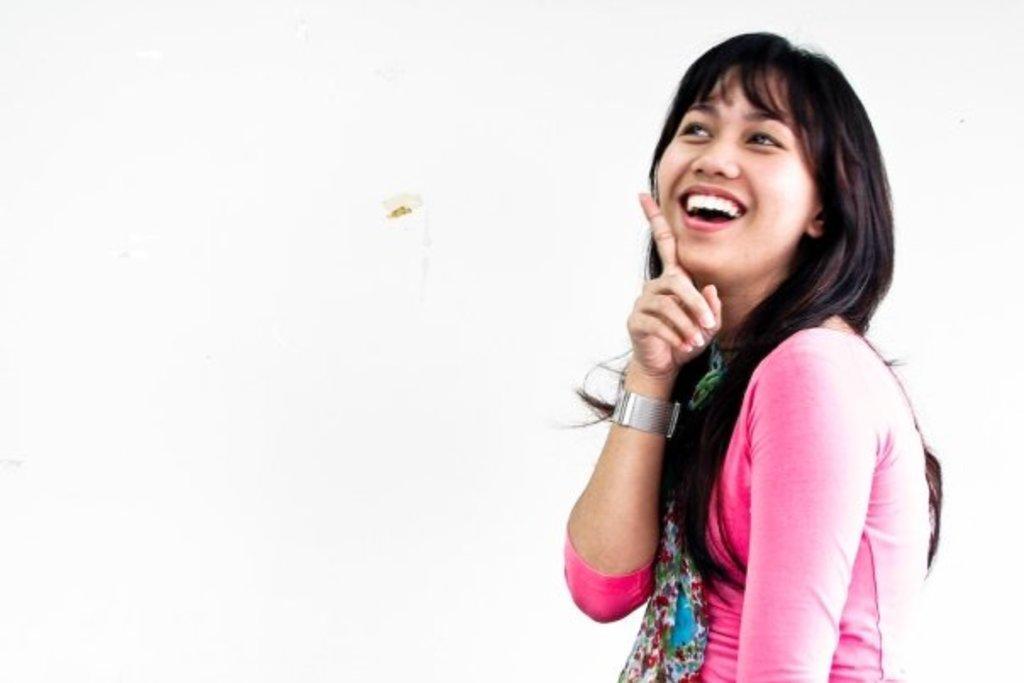Can you describe this image briefly? In this image I can see the person wearing the pink and blue color dress and there is a white background. 